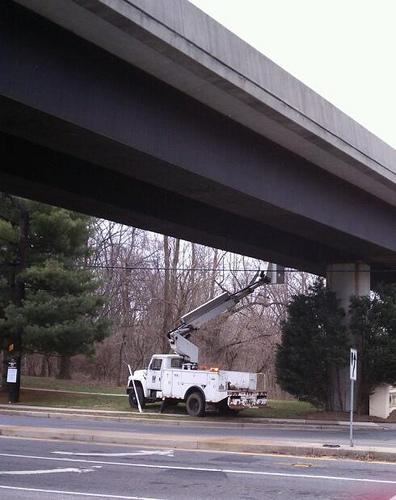Question: how many vehicles are there?
Choices:
A. 2.
B. 1.
C. 3.
D. 4.
Answer with the letter. Answer: B Question: why are there arrows on the road?
Choices:
A. To indicate turn lanes.
B. Guidence.
C. To follow.
D. Rules.
Answer with the letter. Answer: A Question: how many street signs are there?
Choices:
A. 1.
B. 2.
C. 3.
D. 4.
Answer with the letter. Answer: A Question: where is the bridge?
Choices:
A. Above the road.
B. Above the car.
C. Above the man.
D. Above the truck.
Answer with the letter. Answer: D Question: what type of vehicle is there?
Choices:
A. Car.
B. Van.
C. Truck.
D. Bus.
Answer with the letter. Answer: C 